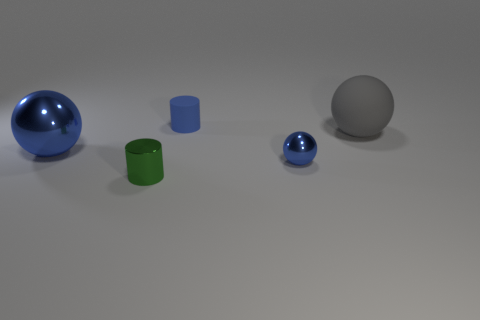What is the material of the tiny blue cylinder?
Provide a short and direct response. Rubber. Is the material of the gray ball the same as the small cylinder to the left of the small rubber thing?
Your answer should be compact. No. Is there any other thing that has the same color as the big rubber thing?
Your answer should be compact. No. Is there a small blue cylinder that is in front of the large blue object left of the shiny ball to the right of the small rubber cylinder?
Provide a succinct answer. No. The big metal object has what color?
Give a very brief answer. Blue. There is a green cylinder; are there any objects in front of it?
Offer a very short reply. No. There is a tiny blue shiny thing; is its shape the same as the tiny blue thing that is to the left of the small blue metal sphere?
Your answer should be compact. No. What number of other things are the same material as the green thing?
Your response must be concise. 2. There is a ball that is on the left side of the blue sphere that is on the right side of the blue sphere on the left side of the tiny green cylinder; what color is it?
Provide a short and direct response. Blue. What shape is the tiny object that is in front of the small shiny object right of the blue rubber thing?
Ensure brevity in your answer.  Cylinder. 